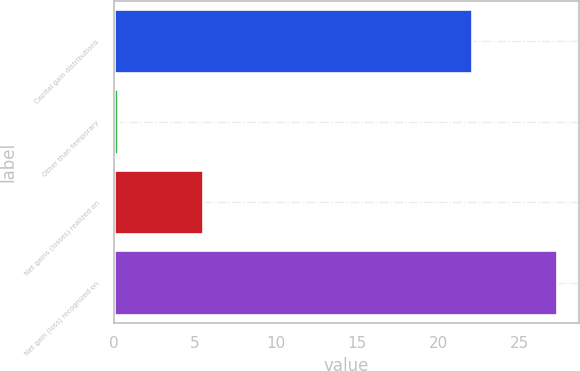<chart> <loc_0><loc_0><loc_500><loc_500><bar_chart><fcel>Capital gain distributions<fcel>Other than temporary<fcel>Net gains (losses) realized on<fcel>Net gain (loss) recognized on<nl><fcel>22.1<fcel>0.3<fcel>5.5<fcel>27.3<nl></chart> 